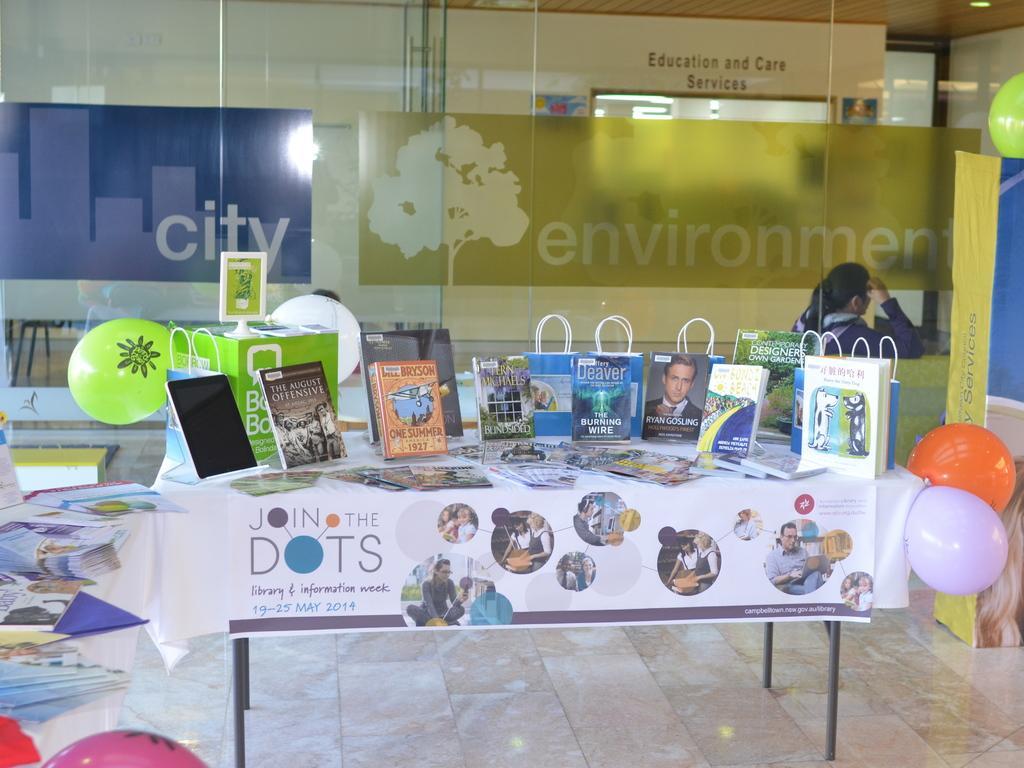Please provide a concise description of this image. In the center of the image we can see books, balloon and covers placed on the table. On the right side of the image we can see an advertisement and balloons. On the left side of the image we can see balloons, books placed on the table. In the background we can see grass, wall, door and advertisement. 